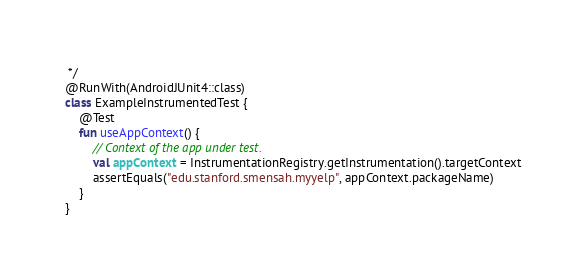Convert code to text. <code><loc_0><loc_0><loc_500><loc_500><_Kotlin_> */
@RunWith(AndroidJUnit4::class)
class ExampleInstrumentedTest {
    @Test
    fun useAppContext() {
        // Context of the app under test.
        val appContext = InstrumentationRegistry.getInstrumentation().targetContext
        assertEquals("edu.stanford.smensah.myyelp", appContext.packageName)
    }
}</code> 